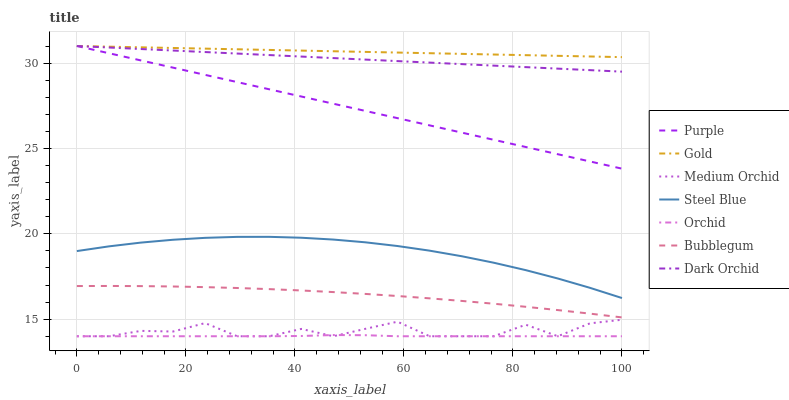Does Orchid have the minimum area under the curve?
Answer yes or no. Yes. Does Gold have the maximum area under the curve?
Answer yes or no. Yes. Does Purple have the minimum area under the curve?
Answer yes or no. No. Does Purple have the maximum area under the curve?
Answer yes or no. No. Is Purple the smoothest?
Answer yes or no. Yes. Is Medium Orchid the roughest?
Answer yes or no. Yes. Is Medium Orchid the smoothest?
Answer yes or no. No. Is Purple the roughest?
Answer yes or no. No. Does Medium Orchid have the lowest value?
Answer yes or no. Yes. Does Purple have the lowest value?
Answer yes or no. No. Does Dark Orchid have the highest value?
Answer yes or no. Yes. Does Medium Orchid have the highest value?
Answer yes or no. No. Is Orchid less than Steel Blue?
Answer yes or no. Yes. Is Gold greater than Medium Orchid?
Answer yes or no. Yes. Does Purple intersect Dark Orchid?
Answer yes or no. Yes. Is Purple less than Dark Orchid?
Answer yes or no. No. Is Purple greater than Dark Orchid?
Answer yes or no. No. Does Orchid intersect Steel Blue?
Answer yes or no. No. 